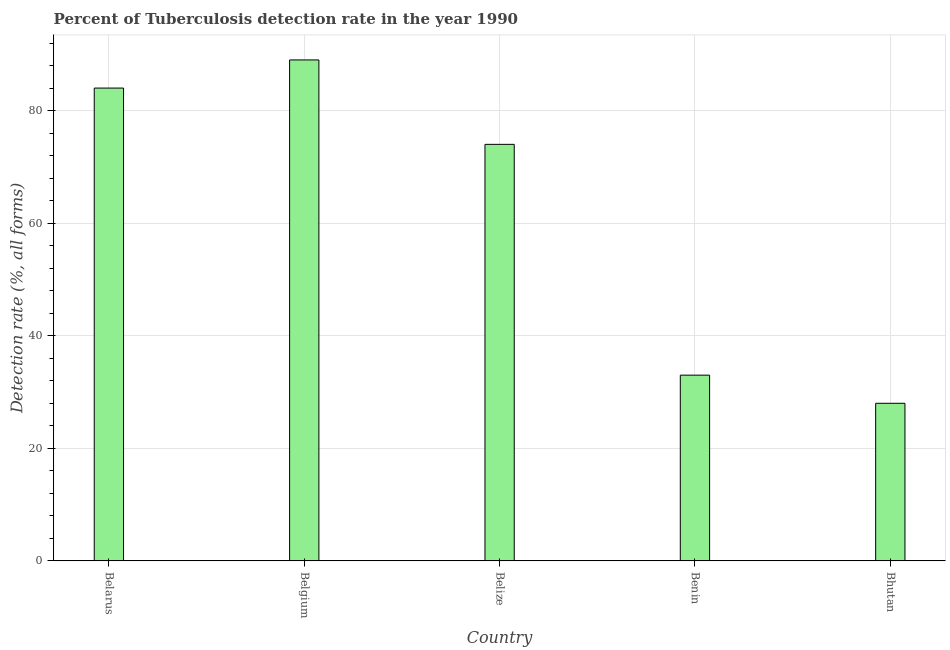What is the title of the graph?
Make the answer very short. Percent of Tuberculosis detection rate in the year 1990. What is the label or title of the X-axis?
Provide a short and direct response. Country. What is the label or title of the Y-axis?
Make the answer very short. Detection rate (%, all forms). What is the detection rate of tuberculosis in Belgium?
Provide a succinct answer. 89. Across all countries, what is the maximum detection rate of tuberculosis?
Keep it short and to the point. 89. In which country was the detection rate of tuberculosis maximum?
Ensure brevity in your answer.  Belgium. In which country was the detection rate of tuberculosis minimum?
Provide a short and direct response. Bhutan. What is the sum of the detection rate of tuberculosis?
Give a very brief answer. 308. What is the average detection rate of tuberculosis per country?
Ensure brevity in your answer.  61.6. In how many countries, is the detection rate of tuberculosis greater than 52 %?
Make the answer very short. 3. What is the ratio of the detection rate of tuberculosis in Belarus to that in Belize?
Your answer should be compact. 1.14. Is the difference between the detection rate of tuberculosis in Belgium and Belize greater than the difference between any two countries?
Your answer should be compact. No. What is the difference between the highest and the second highest detection rate of tuberculosis?
Keep it short and to the point. 5. How many countries are there in the graph?
Provide a succinct answer. 5. What is the difference between two consecutive major ticks on the Y-axis?
Provide a short and direct response. 20. Are the values on the major ticks of Y-axis written in scientific E-notation?
Ensure brevity in your answer.  No. What is the Detection rate (%, all forms) in Belgium?
Keep it short and to the point. 89. What is the Detection rate (%, all forms) in Benin?
Offer a terse response. 33. What is the Detection rate (%, all forms) of Bhutan?
Keep it short and to the point. 28. What is the difference between the Detection rate (%, all forms) in Belarus and Belize?
Keep it short and to the point. 10. What is the difference between the Detection rate (%, all forms) in Belarus and Benin?
Your response must be concise. 51. What is the difference between the Detection rate (%, all forms) in Belarus and Bhutan?
Your answer should be very brief. 56. What is the difference between the Detection rate (%, all forms) in Belgium and Bhutan?
Ensure brevity in your answer.  61. What is the difference between the Detection rate (%, all forms) in Belize and Bhutan?
Your answer should be very brief. 46. What is the ratio of the Detection rate (%, all forms) in Belarus to that in Belgium?
Ensure brevity in your answer.  0.94. What is the ratio of the Detection rate (%, all forms) in Belarus to that in Belize?
Your answer should be compact. 1.14. What is the ratio of the Detection rate (%, all forms) in Belarus to that in Benin?
Your answer should be compact. 2.54. What is the ratio of the Detection rate (%, all forms) in Belarus to that in Bhutan?
Keep it short and to the point. 3. What is the ratio of the Detection rate (%, all forms) in Belgium to that in Belize?
Offer a terse response. 1.2. What is the ratio of the Detection rate (%, all forms) in Belgium to that in Benin?
Your answer should be compact. 2.7. What is the ratio of the Detection rate (%, all forms) in Belgium to that in Bhutan?
Ensure brevity in your answer.  3.18. What is the ratio of the Detection rate (%, all forms) in Belize to that in Benin?
Ensure brevity in your answer.  2.24. What is the ratio of the Detection rate (%, all forms) in Belize to that in Bhutan?
Offer a terse response. 2.64. What is the ratio of the Detection rate (%, all forms) in Benin to that in Bhutan?
Your response must be concise. 1.18. 